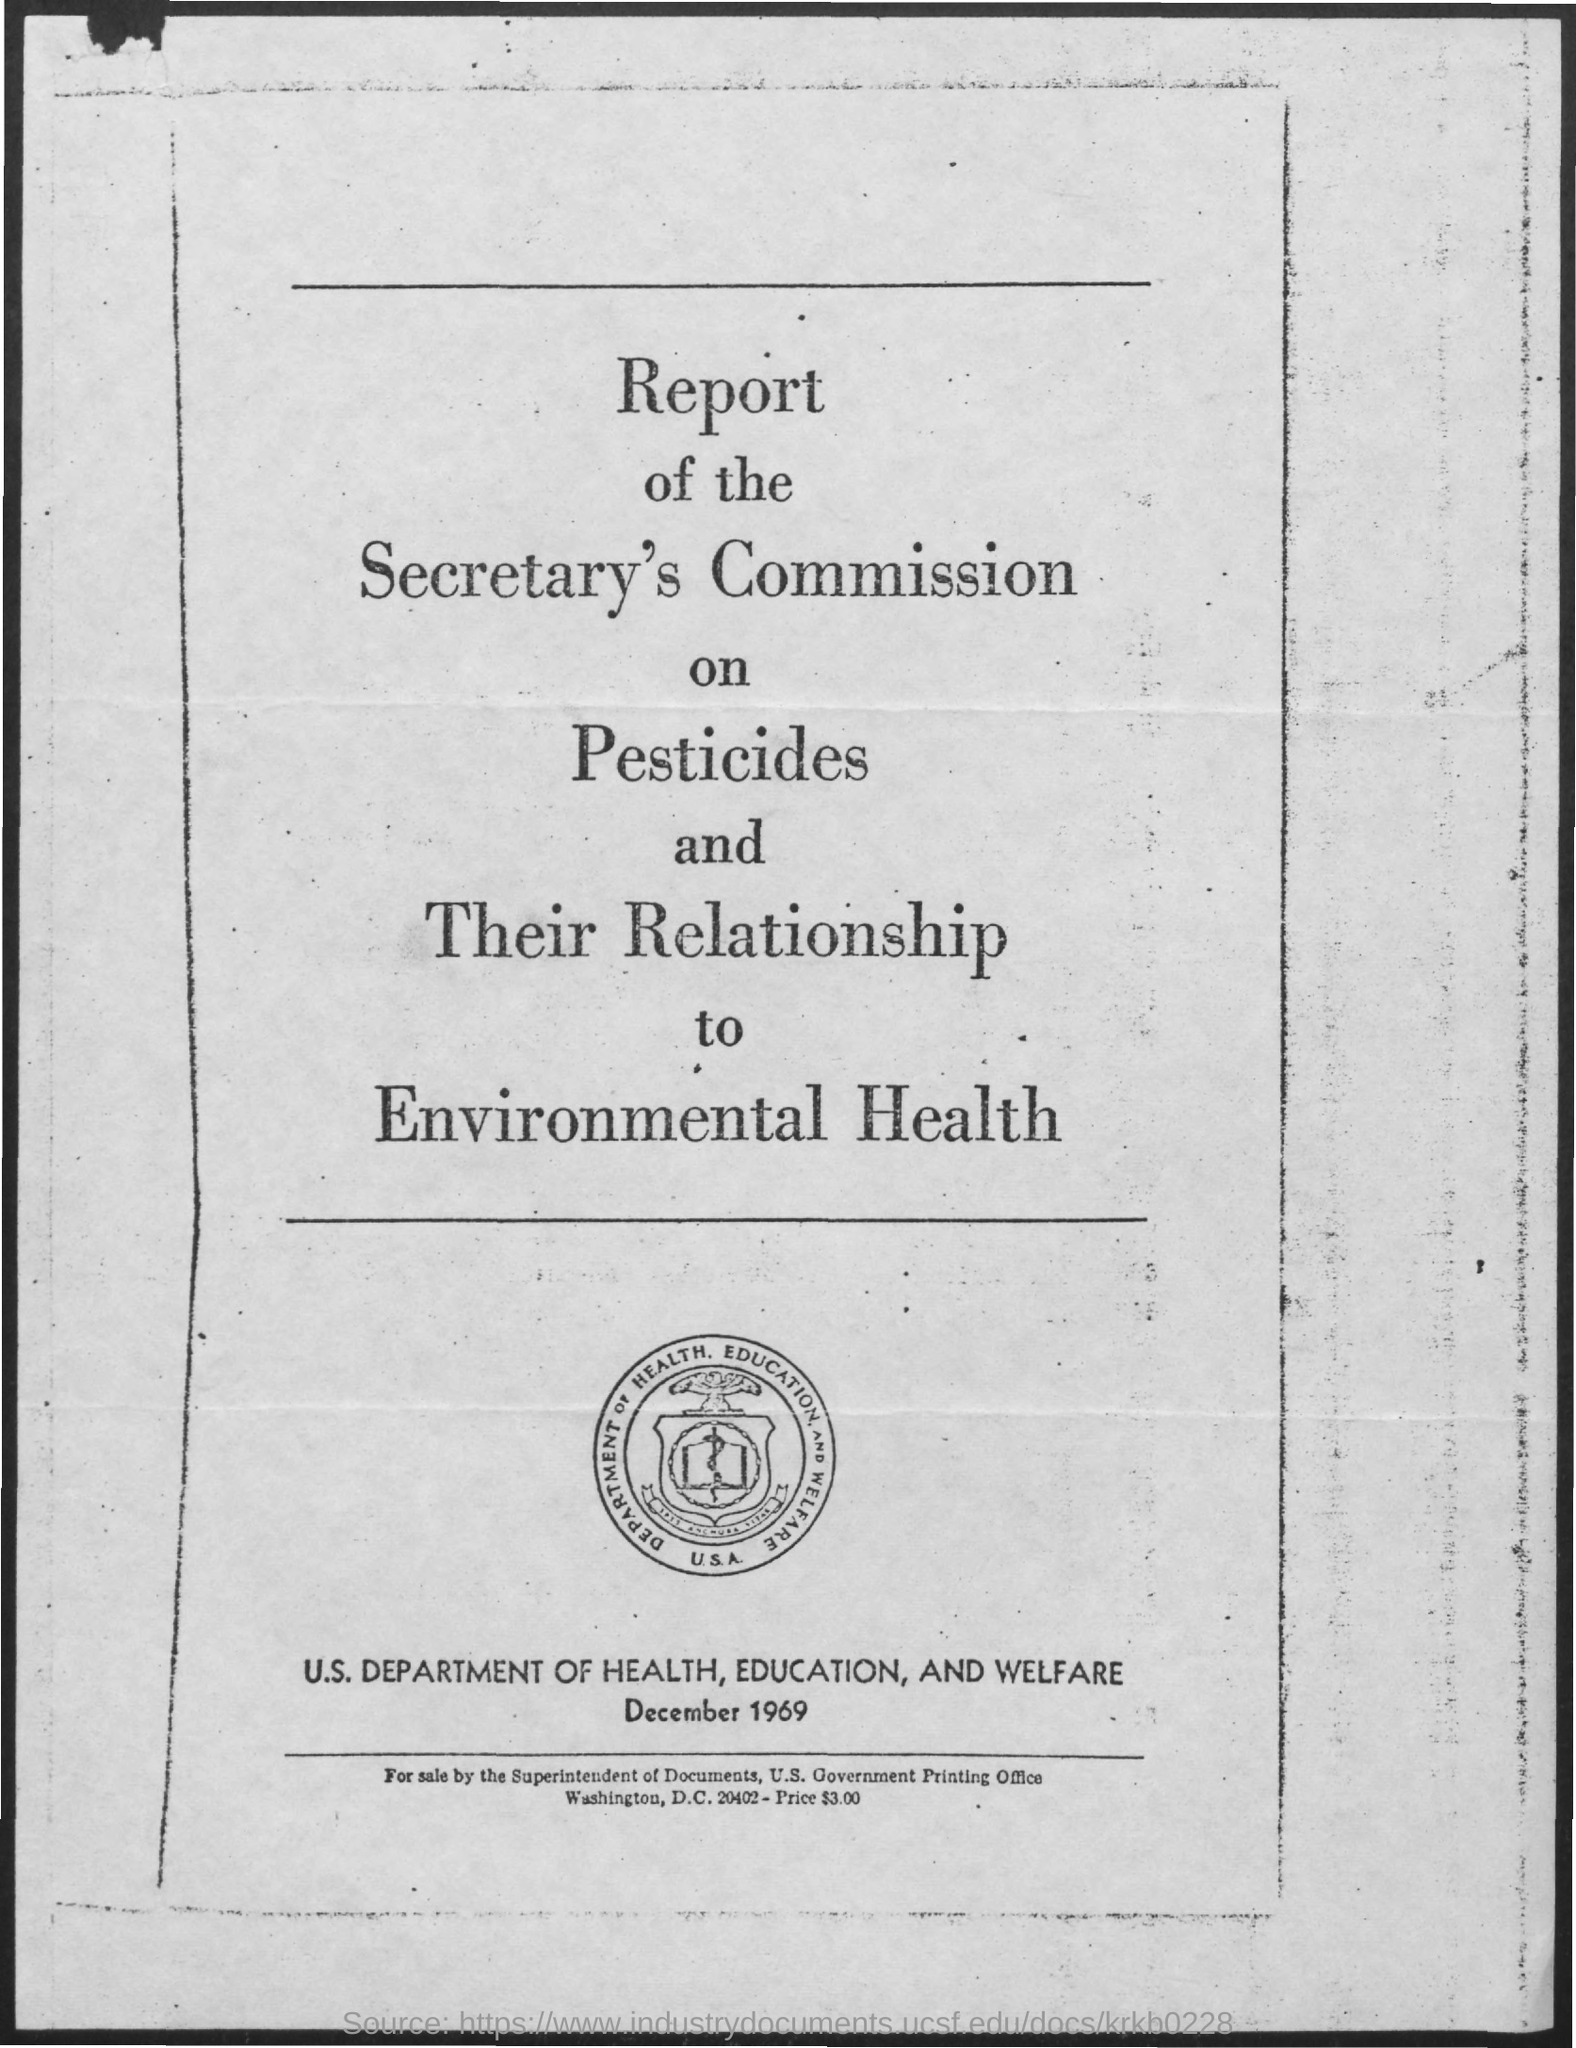Specify some key components in this picture. The Superintendent of Documents, U.S. Government Printing Office, is selling the item. The document contains the date December 1969. 